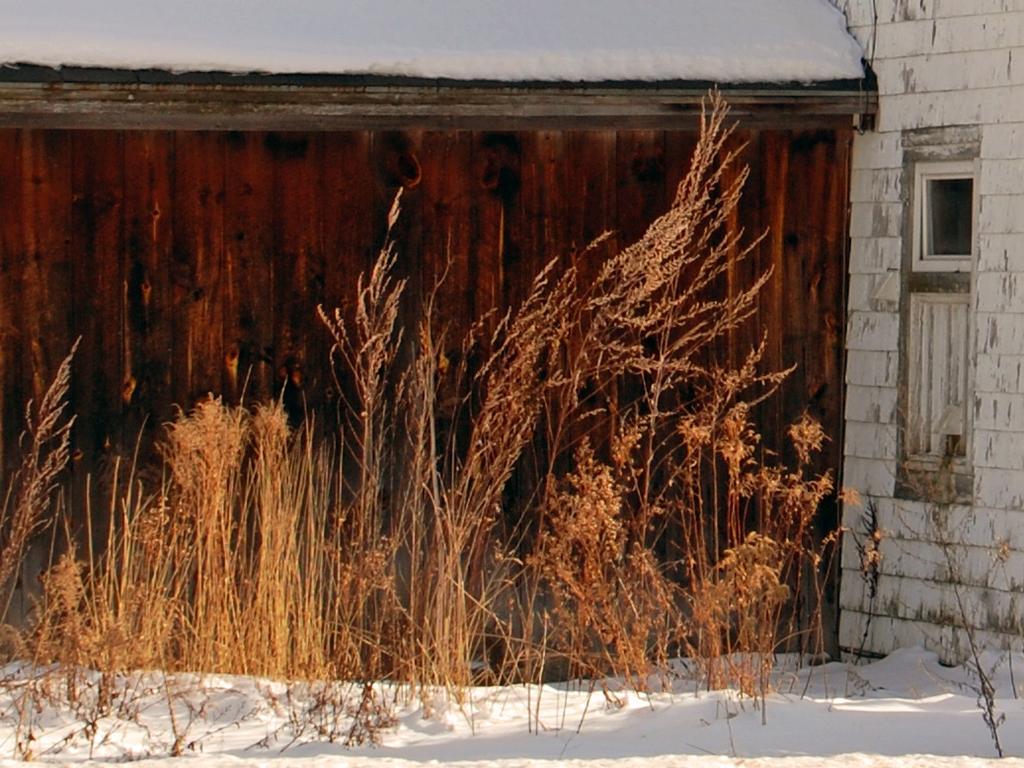What type of vegetation is present in the image? There is grass in the image. What is the grass situated on? The grass is on the snow. What can be seen in the background of the image? There is a building visible in the background of the image. What color is the copper mitten in the image? There is no copper mitten present in the image. Can you describe the relationship between the grass and the parent in the image? There is no parent present in the image, and the relationship between the grass and a parent cannot be determined. 